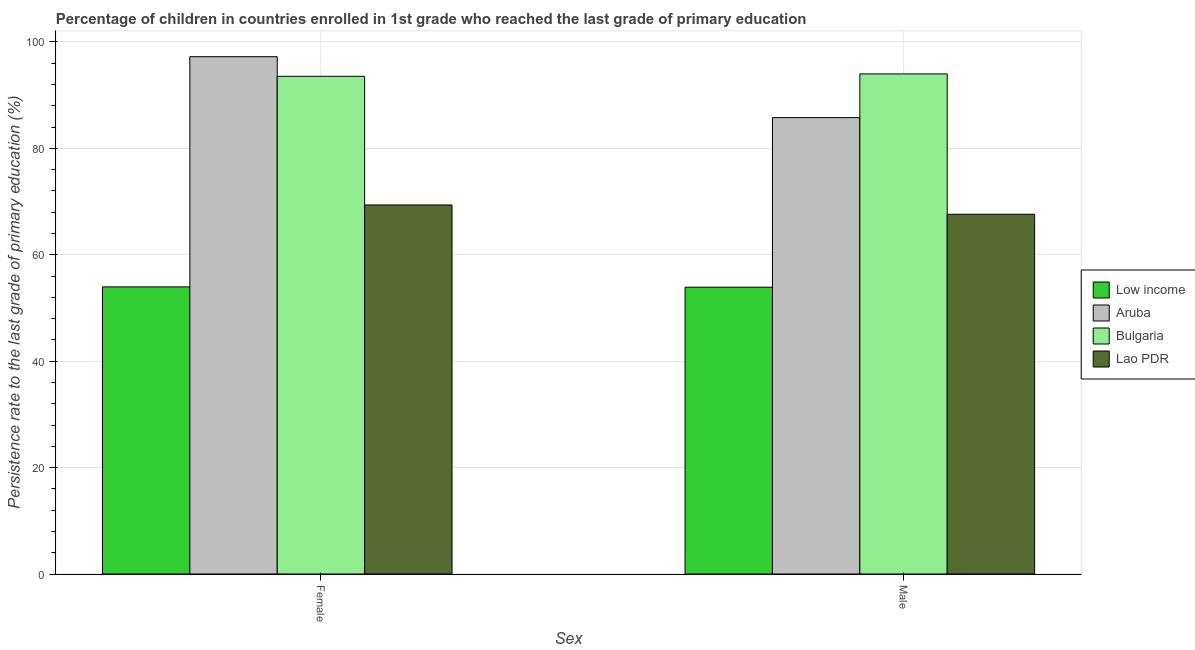Are the number of bars per tick equal to the number of legend labels?
Make the answer very short. Yes. How many bars are there on the 2nd tick from the left?
Your answer should be very brief. 4. How many bars are there on the 2nd tick from the right?
Ensure brevity in your answer.  4. What is the persistence rate of female students in Lao PDR?
Give a very brief answer. 69.36. Across all countries, what is the maximum persistence rate of male students?
Ensure brevity in your answer.  94. Across all countries, what is the minimum persistence rate of female students?
Ensure brevity in your answer.  53.97. What is the total persistence rate of female students in the graph?
Your response must be concise. 314.11. What is the difference between the persistence rate of female students in Low income and that in Lao PDR?
Offer a terse response. -15.39. What is the difference between the persistence rate of female students in Aruba and the persistence rate of male students in Low income?
Provide a short and direct response. 43.33. What is the average persistence rate of female students per country?
Give a very brief answer. 78.53. What is the difference between the persistence rate of female students and persistence rate of male students in Low income?
Keep it short and to the point. 0.07. In how many countries, is the persistence rate of female students greater than 84 %?
Offer a very short reply. 2. What is the ratio of the persistence rate of male students in Lao PDR to that in Aruba?
Give a very brief answer. 0.79. What does the 2nd bar from the left in Male represents?
Your response must be concise. Aruba. What does the 3rd bar from the right in Male represents?
Your answer should be compact. Aruba. What is the difference between two consecutive major ticks on the Y-axis?
Provide a succinct answer. 20. Are the values on the major ticks of Y-axis written in scientific E-notation?
Provide a short and direct response. No. Does the graph contain any zero values?
Give a very brief answer. No. Does the graph contain grids?
Ensure brevity in your answer.  Yes. How many legend labels are there?
Give a very brief answer. 4. How are the legend labels stacked?
Provide a succinct answer. Vertical. What is the title of the graph?
Your response must be concise. Percentage of children in countries enrolled in 1st grade who reached the last grade of primary education. What is the label or title of the X-axis?
Your answer should be very brief. Sex. What is the label or title of the Y-axis?
Your answer should be very brief. Persistence rate to the last grade of primary education (%). What is the Persistence rate to the last grade of primary education (%) in Low income in Female?
Provide a short and direct response. 53.97. What is the Persistence rate to the last grade of primary education (%) in Aruba in Female?
Your response must be concise. 97.23. What is the Persistence rate to the last grade of primary education (%) in Bulgaria in Female?
Ensure brevity in your answer.  93.55. What is the Persistence rate to the last grade of primary education (%) of Lao PDR in Female?
Offer a very short reply. 69.36. What is the Persistence rate to the last grade of primary education (%) of Low income in Male?
Provide a short and direct response. 53.9. What is the Persistence rate to the last grade of primary education (%) of Aruba in Male?
Provide a short and direct response. 85.78. What is the Persistence rate to the last grade of primary education (%) in Bulgaria in Male?
Offer a terse response. 94. What is the Persistence rate to the last grade of primary education (%) of Lao PDR in Male?
Make the answer very short. 67.62. Across all Sex, what is the maximum Persistence rate to the last grade of primary education (%) in Low income?
Give a very brief answer. 53.97. Across all Sex, what is the maximum Persistence rate to the last grade of primary education (%) in Aruba?
Provide a short and direct response. 97.23. Across all Sex, what is the maximum Persistence rate to the last grade of primary education (%) in Bulgaria?
Make the answer very short. 94. Across all Sex, what is the maximum Persistence rate to the last grade of primary education (%) in Lao PDR?
Your answer should be compact. 69.36. Across all Sex, what is the minimum Persistence rate to the last grade of primary education (%) in Low income?
Your answer should be compact. 53.9. Across all Sex, what is the minimum Persistence rate to the last grade of primary education (%) in Aruba?
Give a very brief answer. 85.78. Across all Sex, what is the minimum Persistence rate to the last grade of primary education (%) of Bulgaria?
Your answer should be very brief. 93.55. Across all Sex, what is the minimum Persistence rate to the last grade of primary education (%) of Lao PDR?
Provide a succinct answer. 67.62. What is the total Persistence rate to the last grade of primary education (%) of Low income in the graph?
Make the answer very short. 107.87. What is the total Persistence rate to the last grade of primary education (%) in Aruba in the graph?
Provide a short and direct response. 183.01. What is the total Persistence rate to the last grade of primary education (%) of Bulgaria in the graph?
Offer a terse response. 187.54. What is the total Persistence rate to the last grade of primary education (%) of Lao PDR in the graph?
Your answer should be very brief. 136.98. What is the difference between the Persistence rate to the last grade of primary education (%) of Low income in Female and that in Male?
Ensure brevity in your answer.  0.07. What is the difference between the Persistence rate to the last grade of primary education (%) in Aruba in Female and that in Male?
Ensure brevity in your answer.  11.46. What is the difference between the Persistence rate to the last grade of primary education (%) in Bulgaria in Female and that in Male?
Keep it short and to the point. -0.45. What is the difference between the Persistence rate to the last grade of primary education (%) in Lao PDR in Female and that in Male?
Provide a succinct answer. 1.75. What is the difference between the Persistence rate to the last grade of primary education (%) of Low income in Female and the Persistence rate to the last grade of primary education (%) of Aruba in Male?
Your answer should be very brief. -31.81. What is the difference between the Persistence rate to the last grade of primary education (%) of Low income in Female and the Persistence rate to the last grade of primary education (%) of Bulgaria in Male?
Make the answer very short. -40.03. What is the difference between the Persistence rate to the last grade of primary education (%) in Low income in Female and the Persistence rate to the last grade of primary education (%) in Lao PDR in Male?
Make the answer very short. -13.65. What is the difference between the Persistence rate to the last grade of primary education (%) in Aruba in Female and the Persistence rate to the last grade of primary education (%) in Bulgaria in Male?
Keep it short and to the point. 3.23. What is the difference between the Persistence rate to the last grade of primary education (%) of Aruba in Female and the Persistence rate to the last grade of primary education (%) of Lao PDR in Male?
Give a very brief answer. 29.62. What is the difference between the Persistence rate to the last grade of primary education (%) of Bulgaria in Female and the Persistence rate to the last grade of primary education (%) of Lao PDR in Male?
Provide a short and direct response. 25.93. What is the average Persistence rate to the last grade of primary education (%) of Low income per Sex?
Ensure brevity in your answer.  53.93. What is the average Persistence rate to the last grade of primary education (%) in Aruba per Sex?
Keep it short and to the point. 91.5. What is the average Persistence rate to the last grade of primary education (%) in Bulgaria per Sex?
Offer a terse response. 93.77. What is the average Persistence rate to the last grade of primary education (%) of Lao PDR per Sex?
Your answer should be very brief. 68.49. What is the difference between the Persistence rate to the last grade of primary education (%) of Low income and Persistence rate to the last grade of primary education (%) of Aruba in Female?
Offer a terse response. -43.26. What is the difference between the Persistence rate to the last grade of primary education (%) of Low income and Persistence rate to the last grade of primary education (%) of Bulgaria in Female?
Your response must be concise. -39.58. What is the difference between the Persistence rate to the last grade of primary education (%) of Low income and Persistence rate to the last grade of primary education (%) of Lao PDR in Female?
Your response must be concise. -15.39. What is the difference between the Persistence rate to the last grade of primary education (%) in Aruba and Persistence rate to the last grade of primary education (%) in Bulgaria in Female?
Your answer should be very brief. 3.69. What is the difference between the Persistence rate to the last grade of primary education (%) of Aruba and Persistence rate to the last grade of primary education (%) of Lao PDR in Female?
Provide a short and direct response. 27.87. What is the difference between the Persistence rate to the last grade of primary education (%) of Bulgaria and Persistence rate to the last grade of primary education (%) of Lao PDR in Female?
Your answer should be very brief. 24.18. What is the difference between the Persistence rate to the last grade of primary education (%) in Low income and Persistence rate to the last grade of primary education (%) in Aruba in Male?
Your answer should be very brief. -31.88. What is the difference between the Persistence rate to the last grade of primary education (%) in Low income and Persistence rate to the last grade of primary education (%) in Bulgaria in Male?
Make the answer very short. -40.1. What is the difference between the Persistence rate to the last grade of primary education (%) in Low income and Persistence rate to the last grade of primary education (%) in Lao PDR in Male?
Ensure brevity in your answer.  -13.71. What is the difference between the Persistence rate to the last grade of primary education (%) in Aruba and Persistence rate to the last grade of primary education (%) in Bulgaria in Male?
Give a very brief answer. -8.22. What is the difference between the Persistence rate to the last grade of primary education (%) of Aruba and Persistence rate to the last grade of primary education (%) of Lao PDR in Male?
Your answer should be compact. 18.16. What is the difference between the Persistence rate to the last grade of primary education (%) of Bulgaria and Persistence rate to the last grade of primary education (%) of Lao PDR in Male?
Make the answer very short. 26.38. What is the ratio of the Persistence rate to the last grade of primary education (%) in Aruba in Female to that in Male?
Your response must be concise. 1.13. What is the ratio of the Persistence rate to the last grade of primary education (%) in Bulgaria in Female to that in Male?
Your response must be concise. 1. What is the ratio of the Persistence rate to the last grade of primary education (%) of Lao PDR in Female to that in Male?
Offer a very short reply. 1.03. What is the difference between the highest and the second highest Persistence rate to the last grade of primary education (%) of Low income?
Keep it short and to the point. 0.07. What is the difference between the highest and the second highest Persistence rate to the last grade of primary education (%) in Aruba?
Ensure brevity in your answer.  11.46. What is the difference between the highest and the second highest Persistence rate to the last grade of primary education (%) of Bulgaria?
Your answer should be very brief. 0.45. What is the difference between the highest and the second highest Persistence rate to the last grade of primary education (%) of Lao PDR?
Offer a terse response. 1.75. What is the difference between the highest and the lowest Persistence rate to the last grade of primary education (%) of Low income?
Your response must be concise. 0.07. What is the difference between the highest and the lowest Persistence rate to the last grade of primary education (%) of Aruba?
Your answer should be compact. 11.46. What is the difference between the highest and the lowest Persistence rate to the last grade of primary education (%) in Bulgaria?
Make the answer very short. 0.45. What is the difference between the highest and the lowest Persistence rate to the last grade of primary education (%) of Lao PDR?
Your answer should be compact. 1.75. 